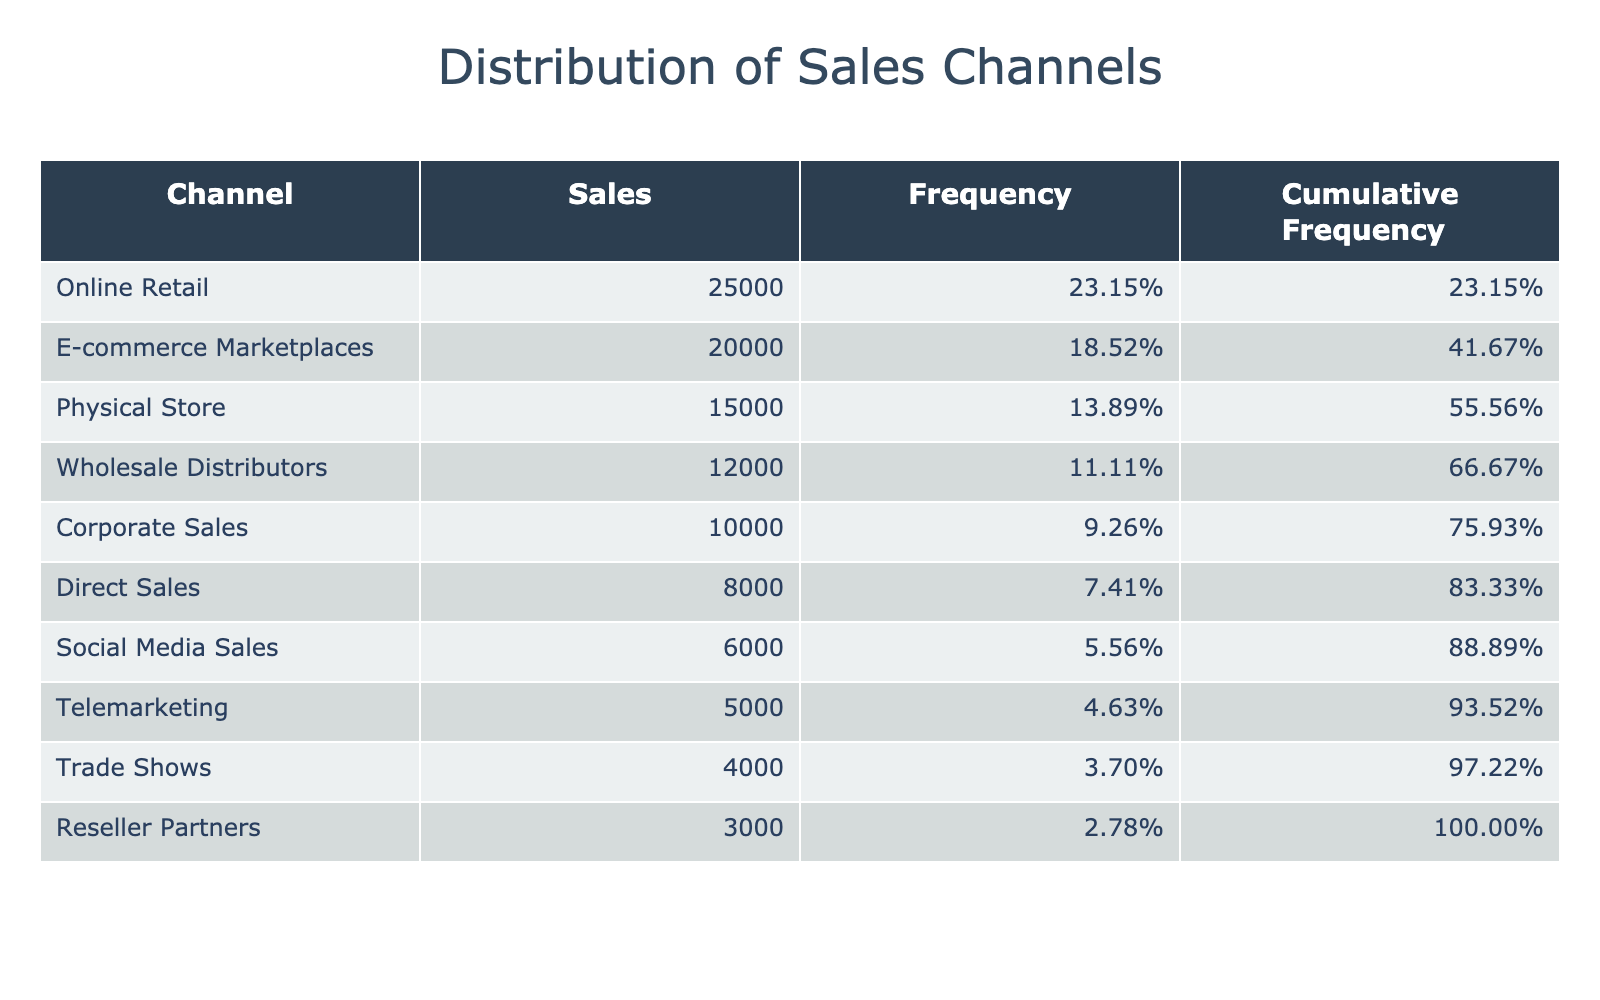What is the total sales across all channels? To find the total sales, I will sum up the sales from each channel: 25000 + 15000 + 12000 + 8000 + 5000 + 3000 + 4000 + 20000 + 6000 + 10000 = 103000.
Answer: 103000 Which channel has the highest sales? Looking at the sales figures, Online Retail has the highest sales with 25000.
Answer: Online Retail What is the frequency distribution percentage for Direct Sales? The frequency for Direct Sales is calculated as (8000 / 103000) * 100% = 7.77%. Additionally, formatting it gives us approximately 7.77%.
Answer: 7.77% Is the sales from E-commerce Marketplaces higher than the sum of sales from Telemarketing and Reseller Partners combined? E-commerce Marketplaces has 20000 and the sum of Telemarketing (5000) and Reseller Partners (3000) is 8000. Since 20000 is greater than 8000, the statement is true.
Answer: Yes What percentage of total sales is accounted for by Physical Store and Corporate Sales combined? To get this, first, sum the sales of Physical Store (15000) and Corporate Sales (10000), giving 25000. Next, I calculate the percentage as (25000 / 103000) * 100% = 24.27%. Therefore, the percentage is approximately 24.27%.
Answer: 24.27% What is the cumulative frequency for wholesaler distributors? The cumulative frequency for Wholesale Distributors is found by adding the frequencies of all preceding channels plus its own. Here, the cumulative frequency is (25000 + 20000 + 15000 + 12000) / 103000 = 0.8679, or approximately 86.79%.
Answer: 86.79% Are the sales through Social Media Sales higher than those through Trade Shows? Social Media Sales is recorded at 6000, and Trade Shows at 4000. Since 6000 is greater than 4000, the answer is yes.
Answer: Yes What is the combined sales total for the top three channels? The top three channels are Online Retail (25000), E-commerce Marketplaces (20000), and Physical Store (15000). The combined sales total is 25000 + 20000 + 15000 = 60000.
Answer: 60000 Which channel contributes most significantly to the cumulative sales by the end of the table? Cumulative sales are highest when reaching the end of the table, at the last channel’s contribution. Since the last entry is Reseller Partners with 3000, the cumulative effect pushes it to the highest value. Therefore, it's the aggregated total.
Answer: Reseller Partners 